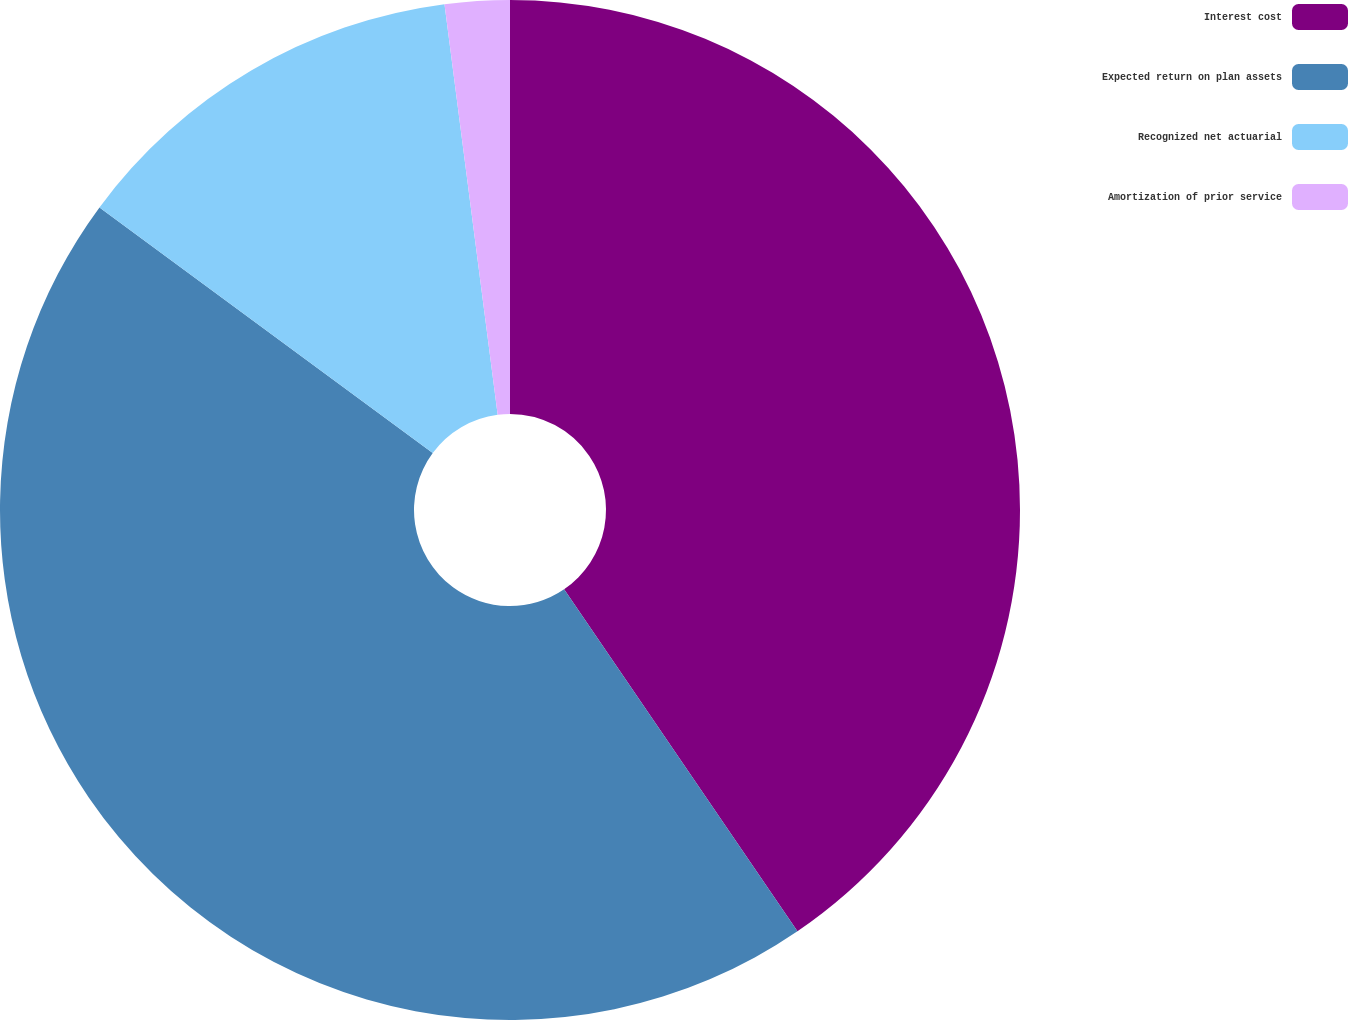Convert chart to OTSL. <chart><loc_0><loc_0><loc_500><loc_500><pie_chart><fcel>Interest cost<fcel>Expected return on plan assets<fcel>Recognized net actuarial<fcel>Amortization of prior service<nl><fcel>40.47%<fcel>44.64%<fcel>12.84%<fcel>2.05%<nl></chart> 